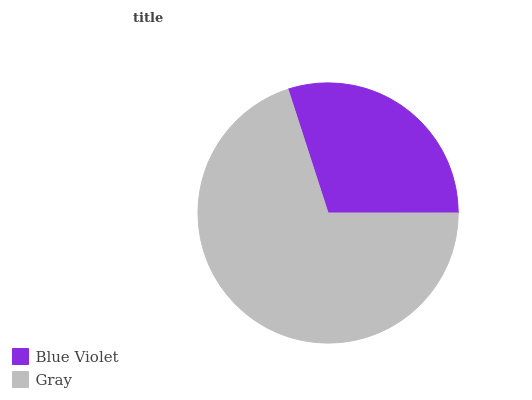Is Blue Violet the minimum?
Answer yes or no. Yes. Is Gray the maximum?
Answer yes or no. Yes. Is Gray the minimum?
Answer yes or no. No. Is Gray greater than Blue Violet?
Answer yes or no. Yes. Is Blue Violet less than Gray?
Answer yes or no. Yes. Is Blue Violet greater than Gray?
Answer yes or no. No. Is Gray less than Blue Violet?
Answer yes or no. No. Is Gray the high median?
Answer yes or no. Yes. Is Blue Violet the low median?
Answer yes or no. Yes. Is Blue Violet the high median?
Answer yes or no. No. Is Gray the low median?
Answer yes or no. No. 